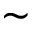<formula> <loc_0><loc_0><loc_500><loc_500>\sim</formula> 